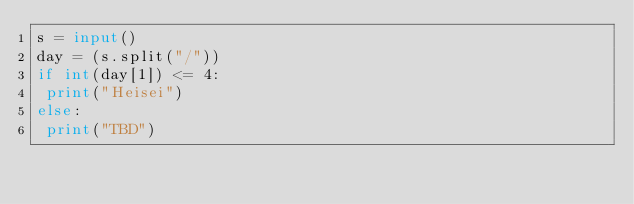Convert code to text. <code><loc_0><loc_0><loc_500><loc_500><_Python_>s = input()
day = (s.split("/"))
if int(day[1]) <= 4:
 print("Heisei")
else:
 print("TBD")</code> 